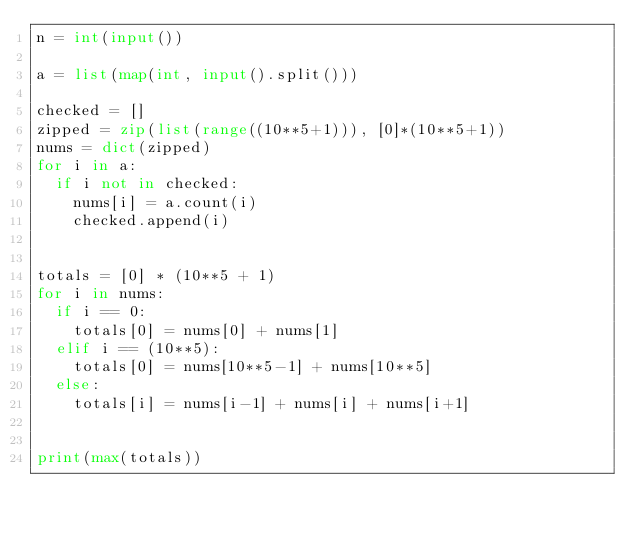<code> <loc_0><loc_0><loc_500><loc_500><_Python_>n = int(input())

a = list(map(int, input().split()))

checked = []
zipped = zip(list(range((10**5+1))), [0]*(10**5+1))
nums = dict(zipped)
for i in a:
  if i not in checked:
    nums[i] = a.count(i)
    checked.append(i)
  
  
totals = [0] * (10**5 + 1)
for i in nums:
  if i == 0:
    totals[0] = nums[0] + nums[1]
  elif i == (10**5):
    totals[0] = nums[10**5-1] + nums[10**5]
  else:
    totals[i] = nums[i-1] + nums[i] + nums[i+1]
  
  
print(max(totals))  </code> 